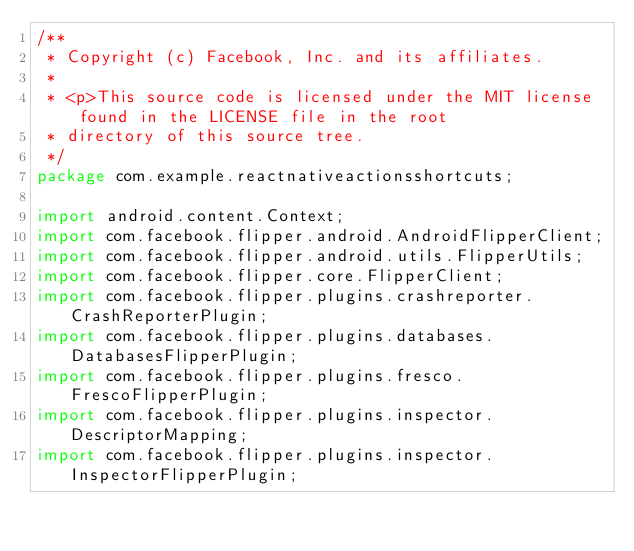<code> <loc_0><loc_0><loc_500><loc_500><_Java_>/**
 * Copyright (c) Facebook, Inc. and its affiliates.
 *
 * <p>This source code is licensed under the MIT license found in the LICENSE file in the root
 * directory of this source tree.
 */
package com.example.reactnativeactionsshortcuts;

import android.content.Context;
import com.facebook.flipper.android.AndroidFlipperClient;
import com.facebook.flipper.android.utils.FlipperUtils;
import com.facebook.flipper.core.FlipperClient;
import com.facebook.flipper.plugins.crashreporter.CrashReporterPlugin;
import com.facebook.flipper.plugins.databases.DatabasesFlipperPlugin;
import com.facebook.flipper.plugins.fresco.FrescoFlipperPlugin;
import com.facebook.flipper.plugins.inspector.DescriptorMapping;
import com.facebook.flipper.plugins.inspector.InspectorFlipperPlugin;</code> 